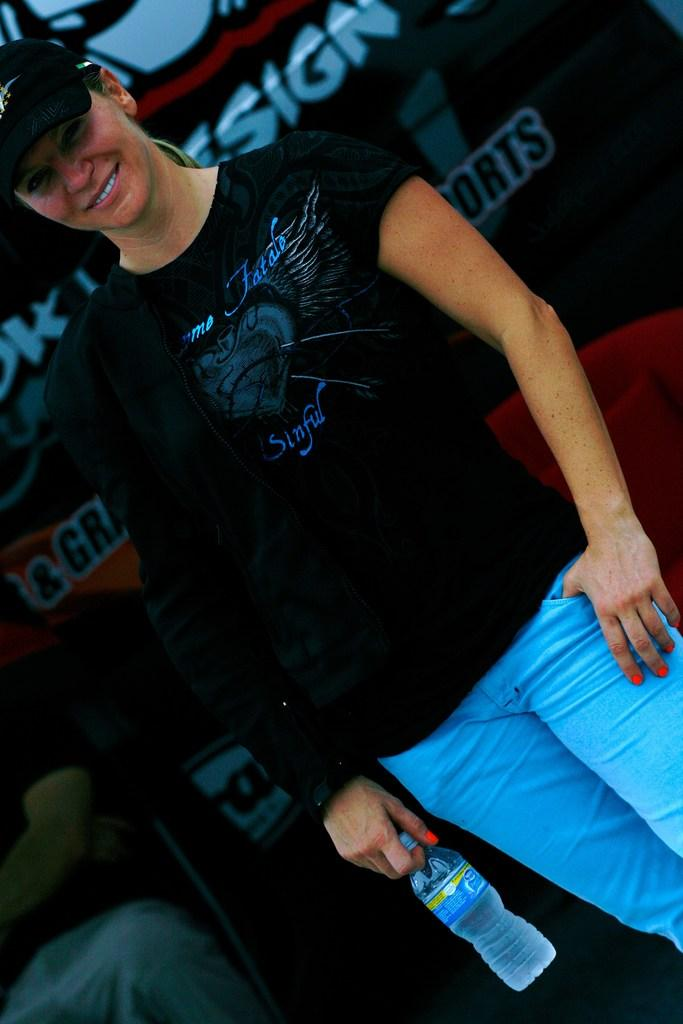What is the woman in the image doing? The woman is standing in the image and smiling. What is the woman holding in her hand? The woman is holding a water bottle in her hand. Can you describe the person sitting on a chair in the image? There is a person sitting on a chair in the image, but no specific details about the person are provided. What type of pleasure is the woman expressing in the image? The image does not indicate any specific type of pleasure being expressed by the woman. 